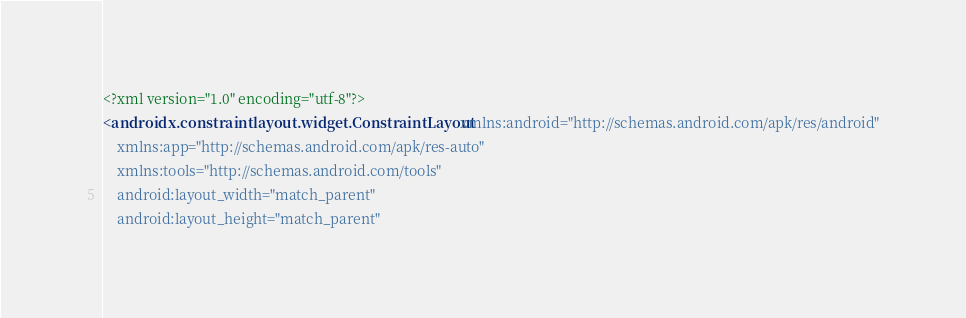Convert code to text. <code><loc_0><loc_0><loc_500><loc_500><_XML_><?xml version="1.0" encoding="utf-8"?>
<androidx.constraintlayout.widget.ConstraintLayout xmlns:android="http://schemas.android.com/apk/res/android"
    xmlns:app="http://schemas.android.com/apk/res-auto"
    xmlns:tools="http://schemas.android.com/tools"
    android:layout_width="match_parent"
    android:layout_height="match_parent"</code> 